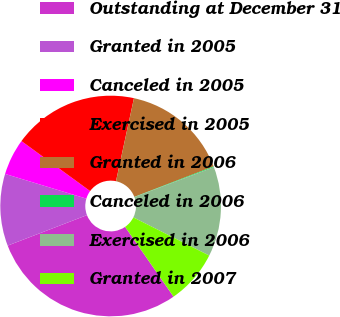Convert chart to OTSL. <chart><loc_0><loc_0><loc_500><loc_500><pie_chart><fcel>Outstanding at December 31<fcel>Granted in 2005<fcel>Canceled in 2005<fcel>Exercised in 2005<fcel>Granted in 2006<fcel>Canceled in 2006<fcel>Exercised in 2006<fcel>Granted in 2007<nl><fcel>28.81%<fcel>10.54%<fcel>5.32%<fcel>18.37%<fcel>15.76%<fcel>0.11%<fcel>13.15%<fcel>7.93%<nl></chart> 